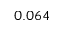<formula> <loc_0><loc_0><loc_500><loc_500>0 . 0 6 4</formula> 